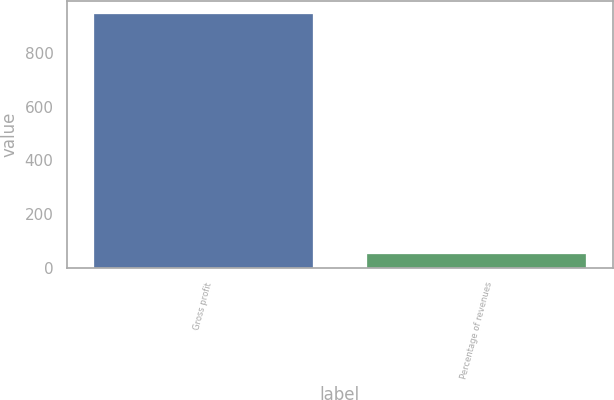Convert chart to OTSL. <chart><loc_0><loc_0><loc_500><loc_500><bar_chart><fcel>Gross profit<fcel>Percentage of revenues<nl><fcel>944.4<fcel>52.2<nl></chart> 